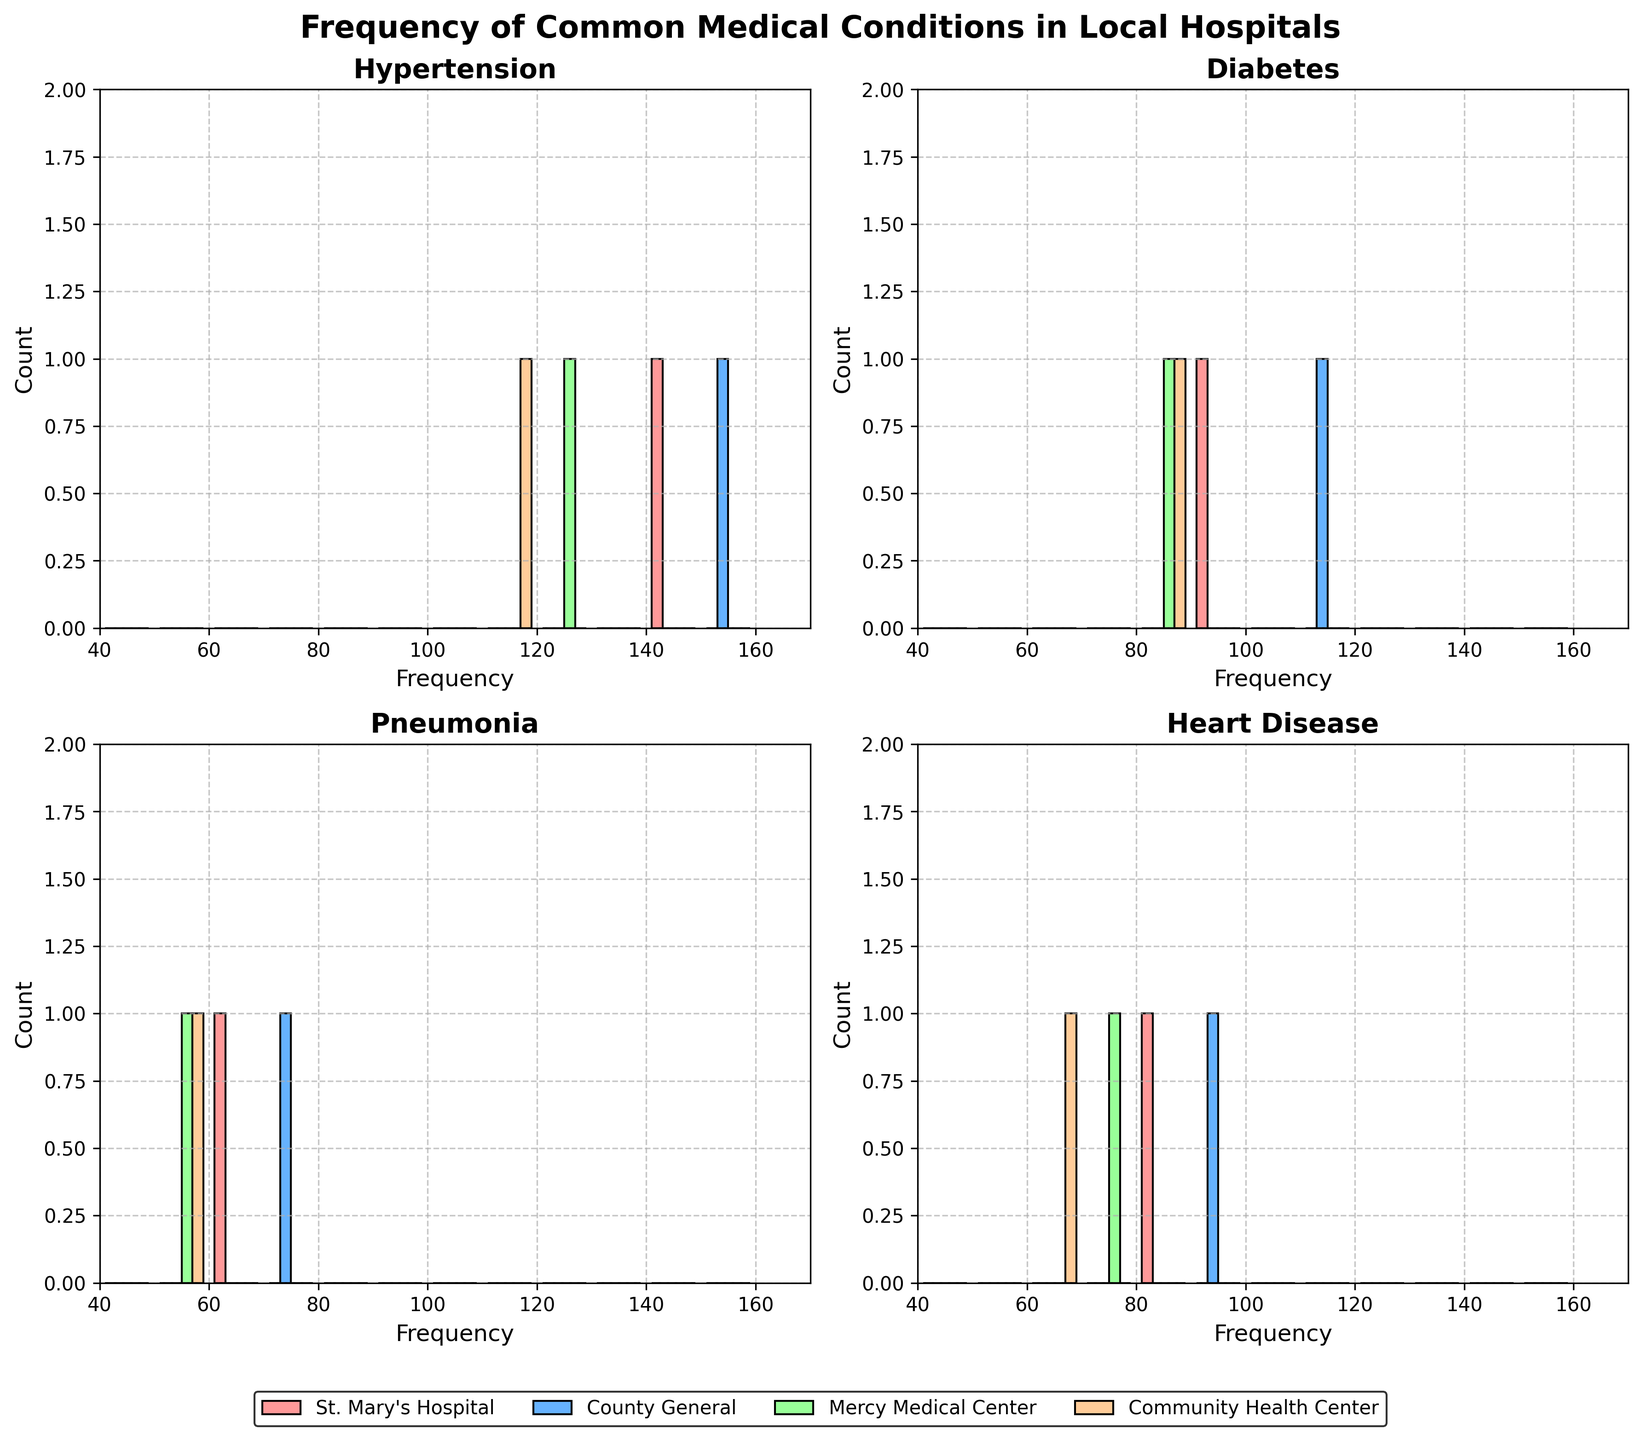What is the title of the figure? The title is usually displayed at the top of the figure as a headline. It captures the main idea of the visualization.
Answer: Frequency of Common Medical Conditions in Local Hospitals Which condition shows the highest frequency in St. Mary's Hospital? Inspect the histogram subplot for St. Mary's Hospital. Identify the bar with the highest peak for each condition.
Answer: Hypertension Which hospital has the lowest frequency for pneumonia? Look for the histogram bar representing pneumonia in each subplot and compare the heights of the bars.
Answer: Community Health Center What is the range of the x-axis in the subplots? The x-axis range is indicated by the tick marks at the bottom of each subplot.
Answer: 40 to 170 What color represents Mercy Medical Center in the histograms? Review the legend that matches hospitals with colors displayed below the plots.
Answer: Light green How does the frequency of diabetes in Community Health Center compare to Mercy Medical Center? Compare the heights of the histogram bars representing diabetes for the two hospitals to determine which is higher.
Answer: Community Health Center has a lower frequency than Mercy Medical Center Which condition has the smallest variation in frequency across all hospitals? Compare the heights of the histogram bars for each condition across the four histograms to determine which has the smallest difference in height.
Answer: Pneumonia How many hospitals have a heart disease frequency over 80? Count the number of bars in the heart disease subplot (bottom right) that exceed the 80 mark on the x-axis.
Answer: Three Which histogram shows the highest variance in frequencies among the hospitals? Evaluate the variations in bar heights within each subplot. The subplot with the greatest difference between the tallest and shortest bars will have the highest variance.
Answer: Hypertension 